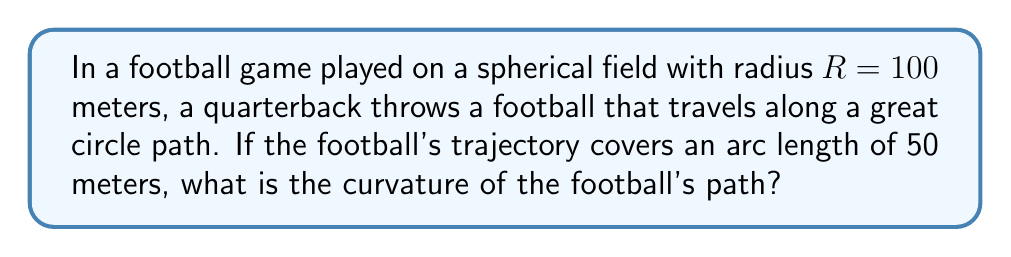What is the answer to this math problem? Let's approach this step-by-step:

1) In non-Euclidean geometry, specifically on a sphere, the curvature of a great circle is constant and equal to the reciprocal of the sphere's radius.

2) The formula for the curvature $\kappa$ of a great circle on a sphere is:

   $$\kappa = \frac{1}{R}$$

   where $R$ is the radius of the sphere.

3) In this case, we're given that $R = 100$ meters.

4) Substituting this into our formula:

   $$\kappa = \frac{1}{100} = 0.01 \text{ m}^{-1}$$

5) Note that the arc length of the trajectory (50 meters) doesn't affect the curvature calculation. On a sphere, all great circles have the same constant curvature regardless of the length of the path traveled.

6) The units of curvature are the reciprocal of length, in this case $\text{m}^{-1}$.
Answer: $0.01 \text{ m}^{-1}$ 